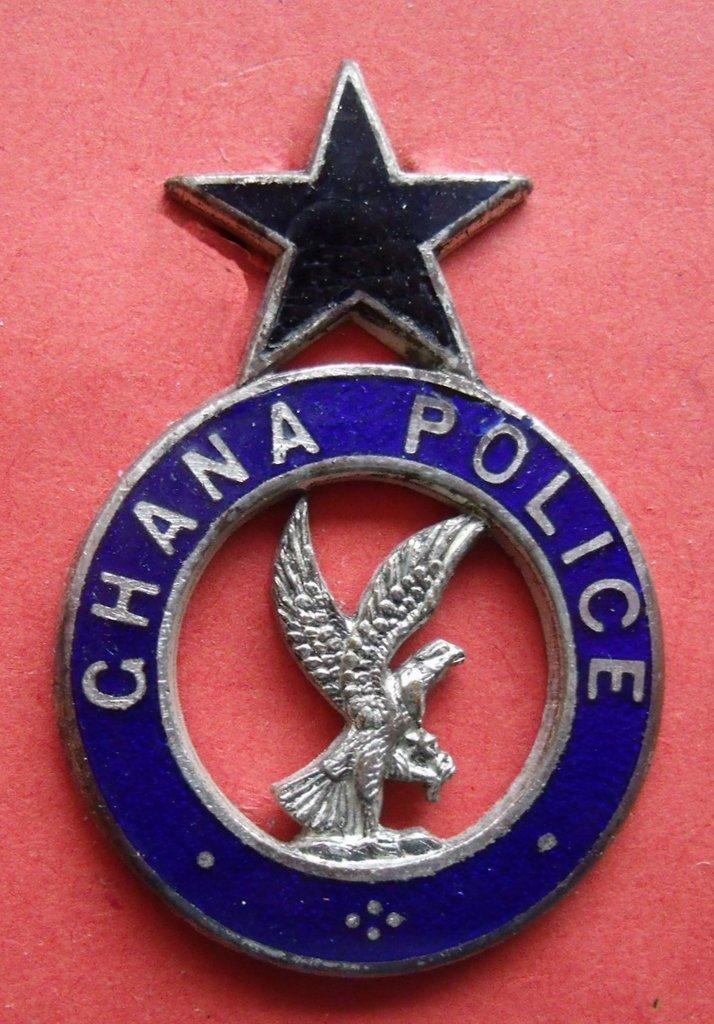What is the main object in the image? There is a badge in the image. What colors are present on the badge? The badge has black, blue, and silver colors. What text is written on the blue part of the badge? The text "Chana Police" is written on the blue part of the badge. What is the background color of the badge? The badge is on a red surface. Is there any lace visible on the badge in the image? No, there is no lace present on the badge in the image. 